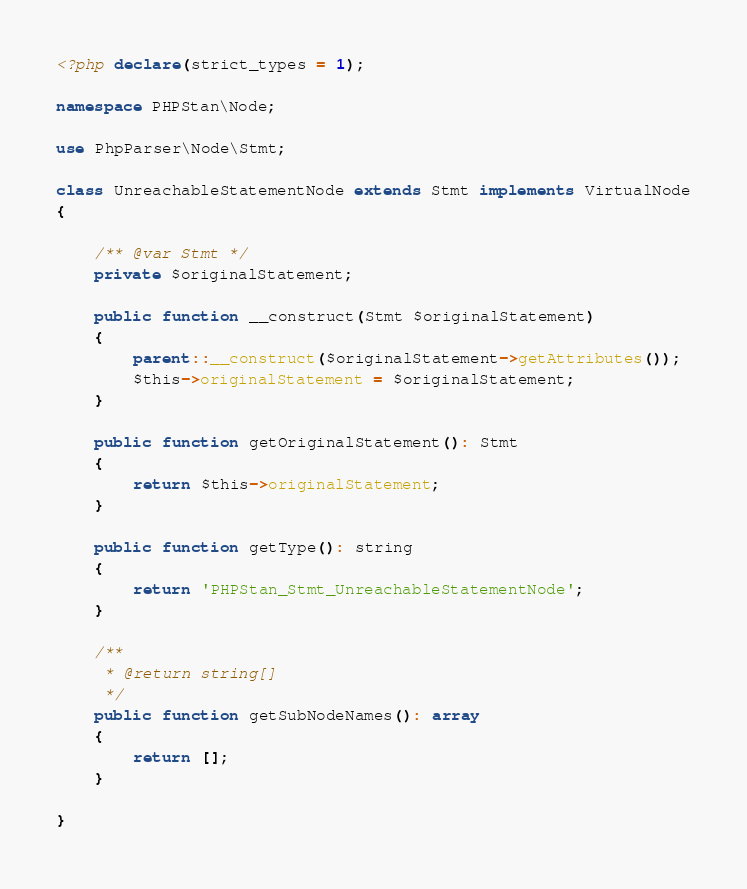<code> <loc_0><loc_0><loc_500><loc_500><_PHP_><?php declare(strict_types = 1);

namespace PHPStan\Node;

use PhpParser\Node\Stmt;

class UnreachableStatementNode extends Stmt implements VirtualNode
{

	/** @var Stmt */
	private $originalStatement;

	public function __construct(Stmt $originalStatement)
	{
		parent::__construct($originalStatement->getAttributes());
		$this->originalStatement = $originalStatement;
	}

	public function getOriginalStatement(): Stmt
	{
		return $this->originalStatement;
	}

	public function getType(): string
	{
		return 'PHPStan_Stmt_UnreachableStatementNode';
	}

	/**
	 * @return string[]
	 */
	public function getSubNodeNames(): array
	{
		return [];
	}

}
</code> 